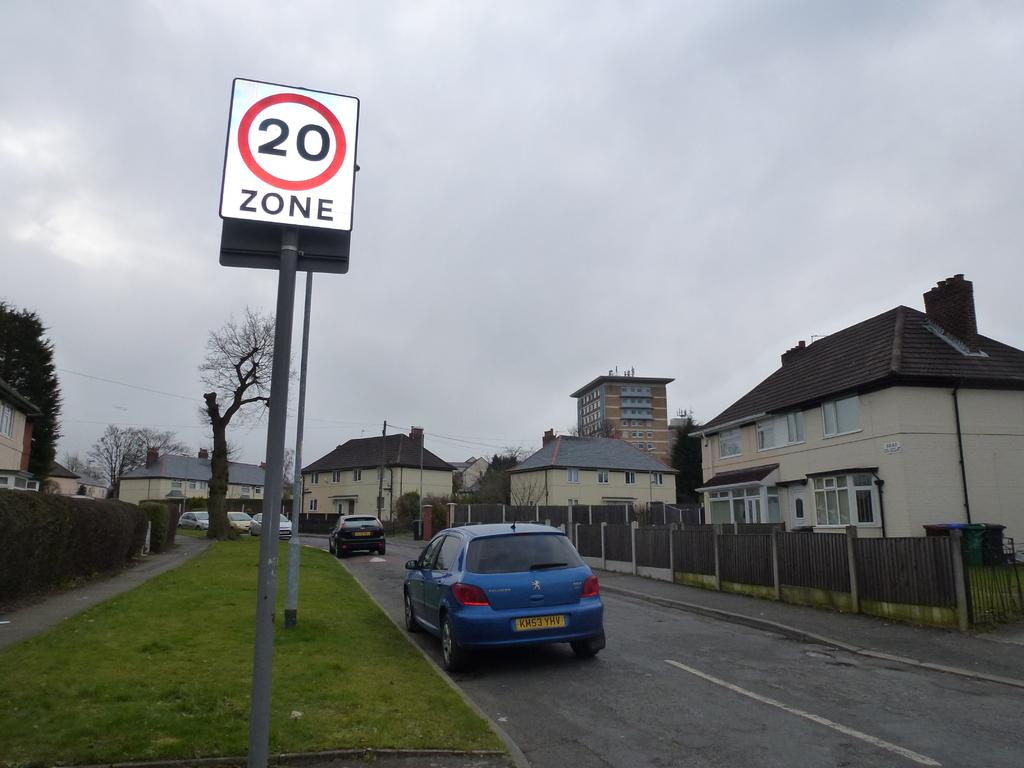<image>
Describe the image concisely. A village with a speed limit sign of 20. 